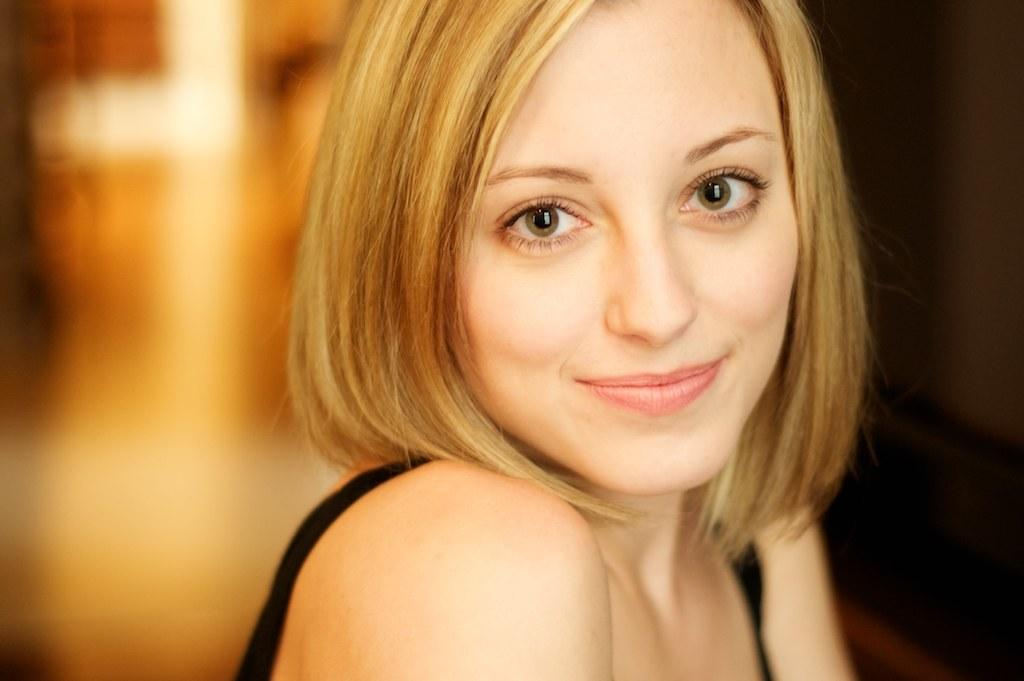What is the main subject of the image? There is a woman in the image. Can you describe the background of the image? The background of the image is blurred. What is the woman's grandfather doing in the image? There is no mention of a grandfather in the image, so it cannot be determined what he might be doing. 